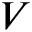<formula> <loc_0><loc_0><loc_500><loc_500>V</formula> 